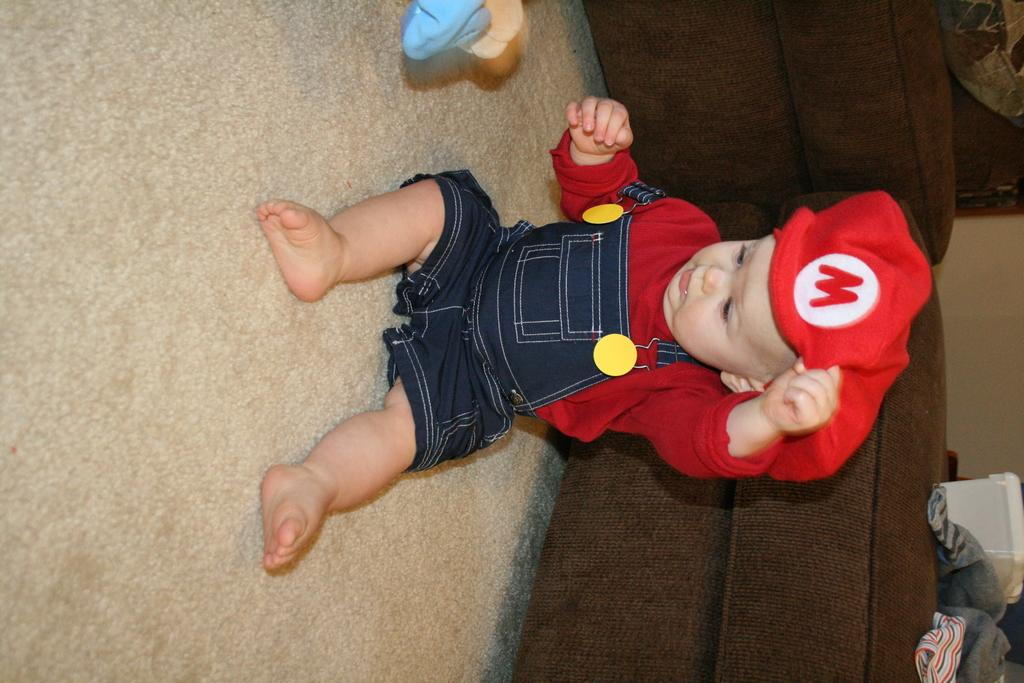What is the main subject of the image? The main subject of the image is a baby. Where is the baby located in the image? The baby is sitting on the floor. What is the baby wearing on their upper body? The baby is wearing a red color t-shirt. What type of headwear is the baby wearing? The baby is wearing a cap. What type of machine can be seen operating in the background of the image? There is no machine present in the image; it features a baby sitting on the floor. What type of oven is visible in the image? There is no oven present in the image. 